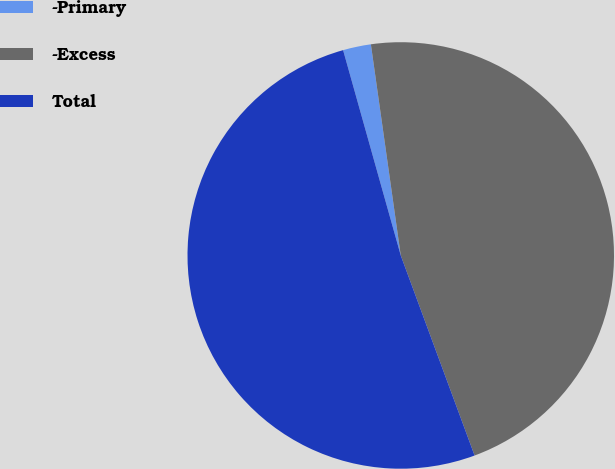<chart> <loc_0><loc_0><loc_500><loc_500><pie_chart><fcel>-Primary<fcel>-Excess<fcel>Total<nl><fcel>2.12%<fcel>46.61%<fcel>51.27%<nl></chart> 